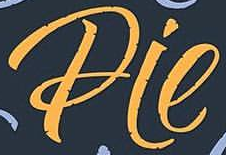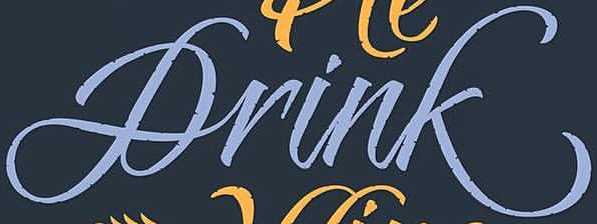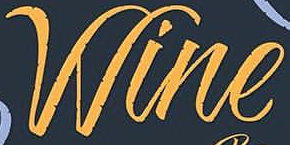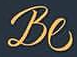What words can you see in these images in sequence, separated by a semicolon? Pie; Drink; Wine; Be 